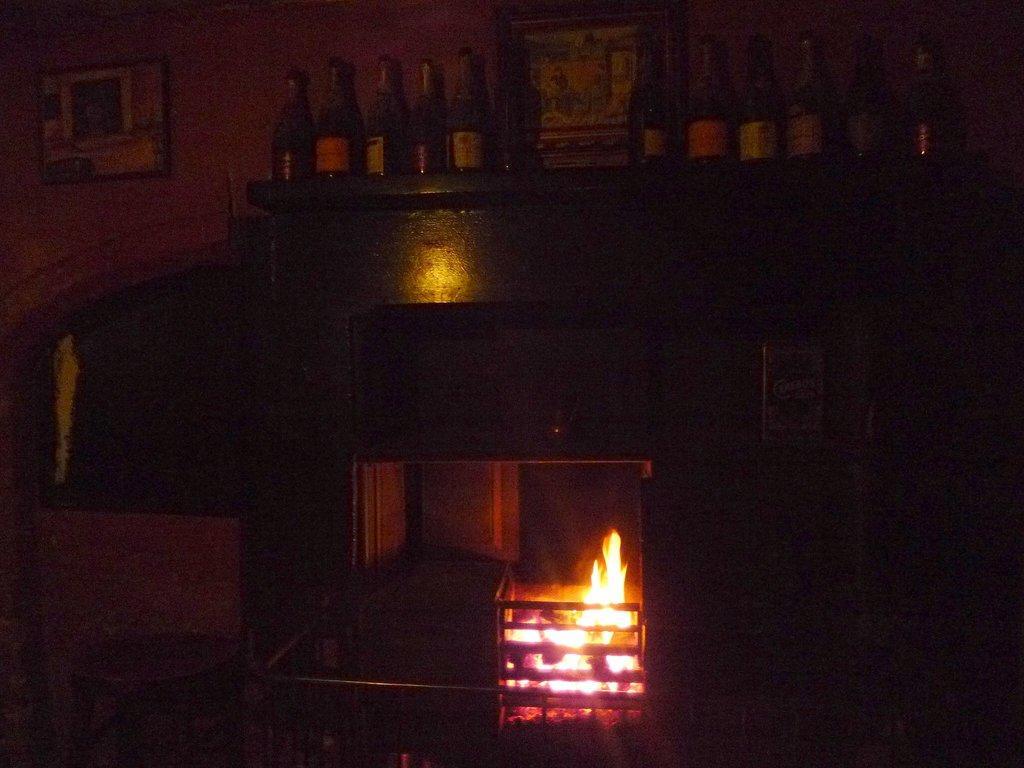How would you summarize this image in a sentence or two? This is the picture of a room. In this image there are bottles on the table. At the bottom there is a flame. At the back there are frames on the wall. On the left side of the image there is a stool. 